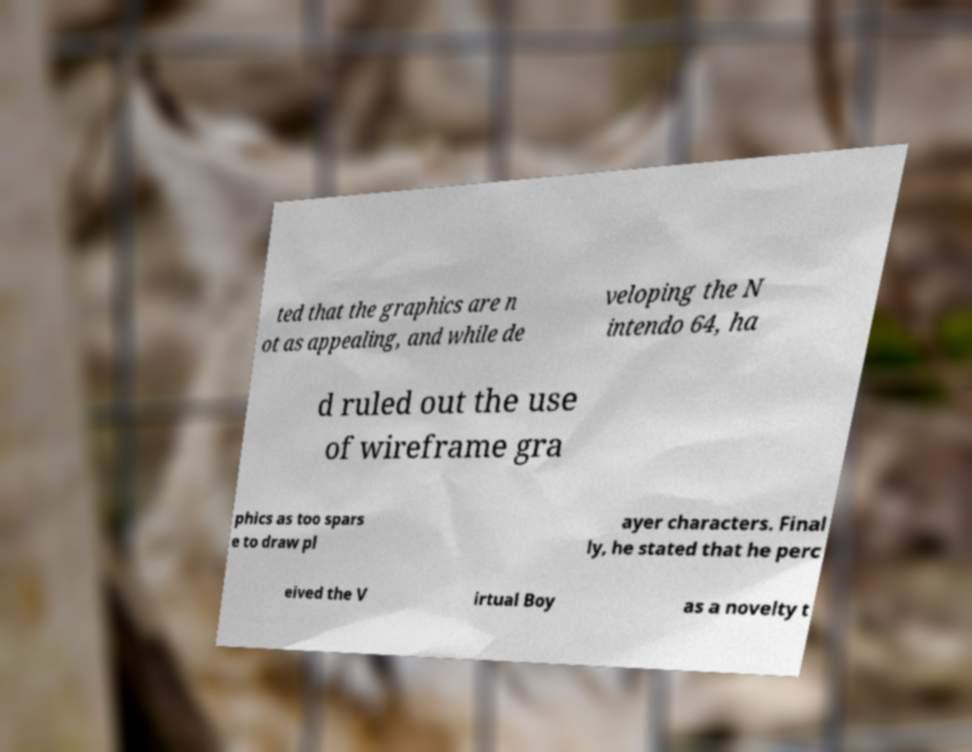Please read and relay the text visible in this image. What does it say? ted that the graphics are n ot as appealing, and while de veloping the N intendo 64, ha d ruled out the use of wireframe gra phics as too spars e to draw pl ayer characters. Final ly, he stated that he perc eived the V irtual Boy as a novelty t 